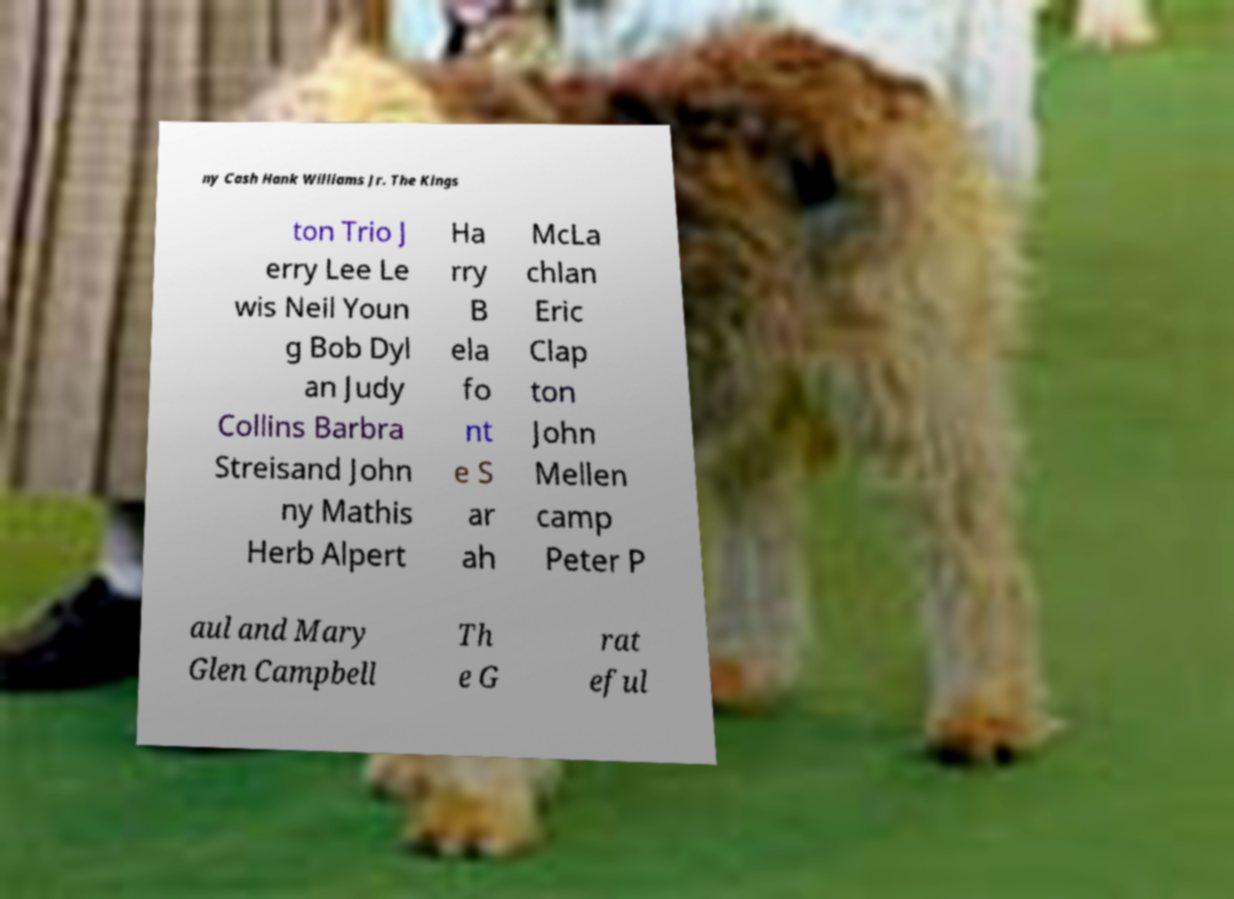I need the written content from this picture converted into text. Can you do that? ny Cash Hank Williams Jr. The Kings ton Trio J erry Lee Le wis Neil Youn g Bob Dyl an Judy Collins Barbra Streisand John ny Mathis Herb Alpert Ha rry B ela fo nt e S ar ah McLa chlan Eric Clap ton John Mellen camp Peter P aul and Mary Glen Campbell Th e G rat eful 